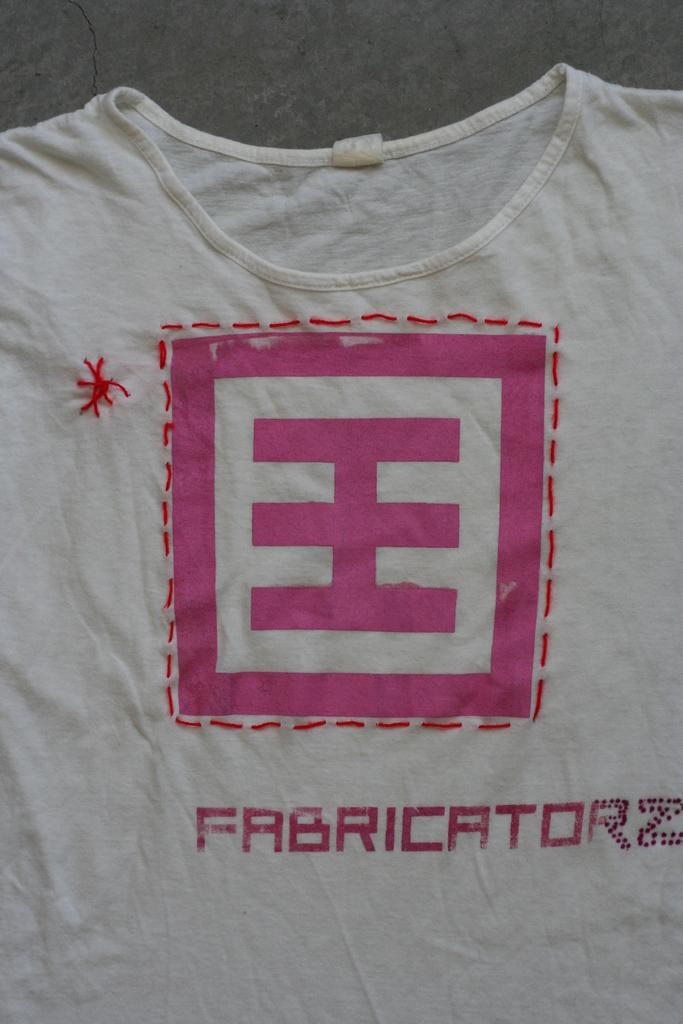What type of clothing item is in the image? There is a t-shirt in the image. What color is the t-shirt? The t-shirt is white. What design elements are present on the t-shirt? The t-shirt has a logo and some text. What type of breakfast is being served on the t-shirt? There is no breakfast depicted on the t-shirt; it only features a logo and text. 